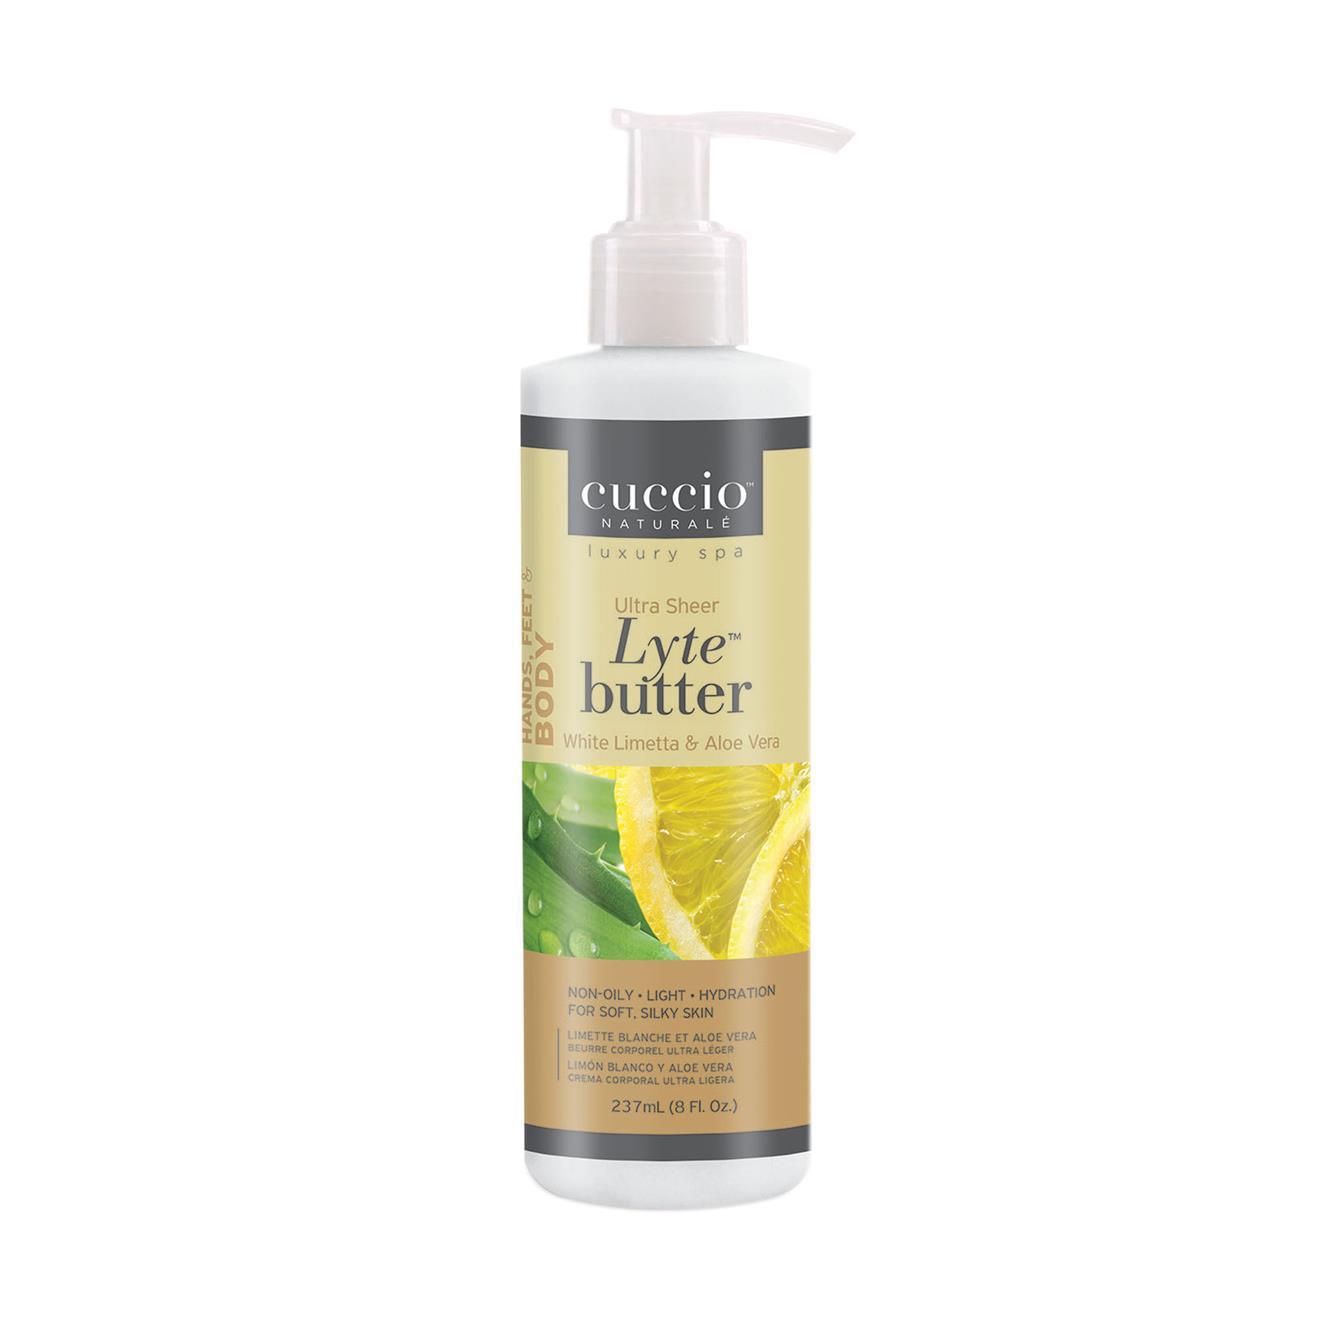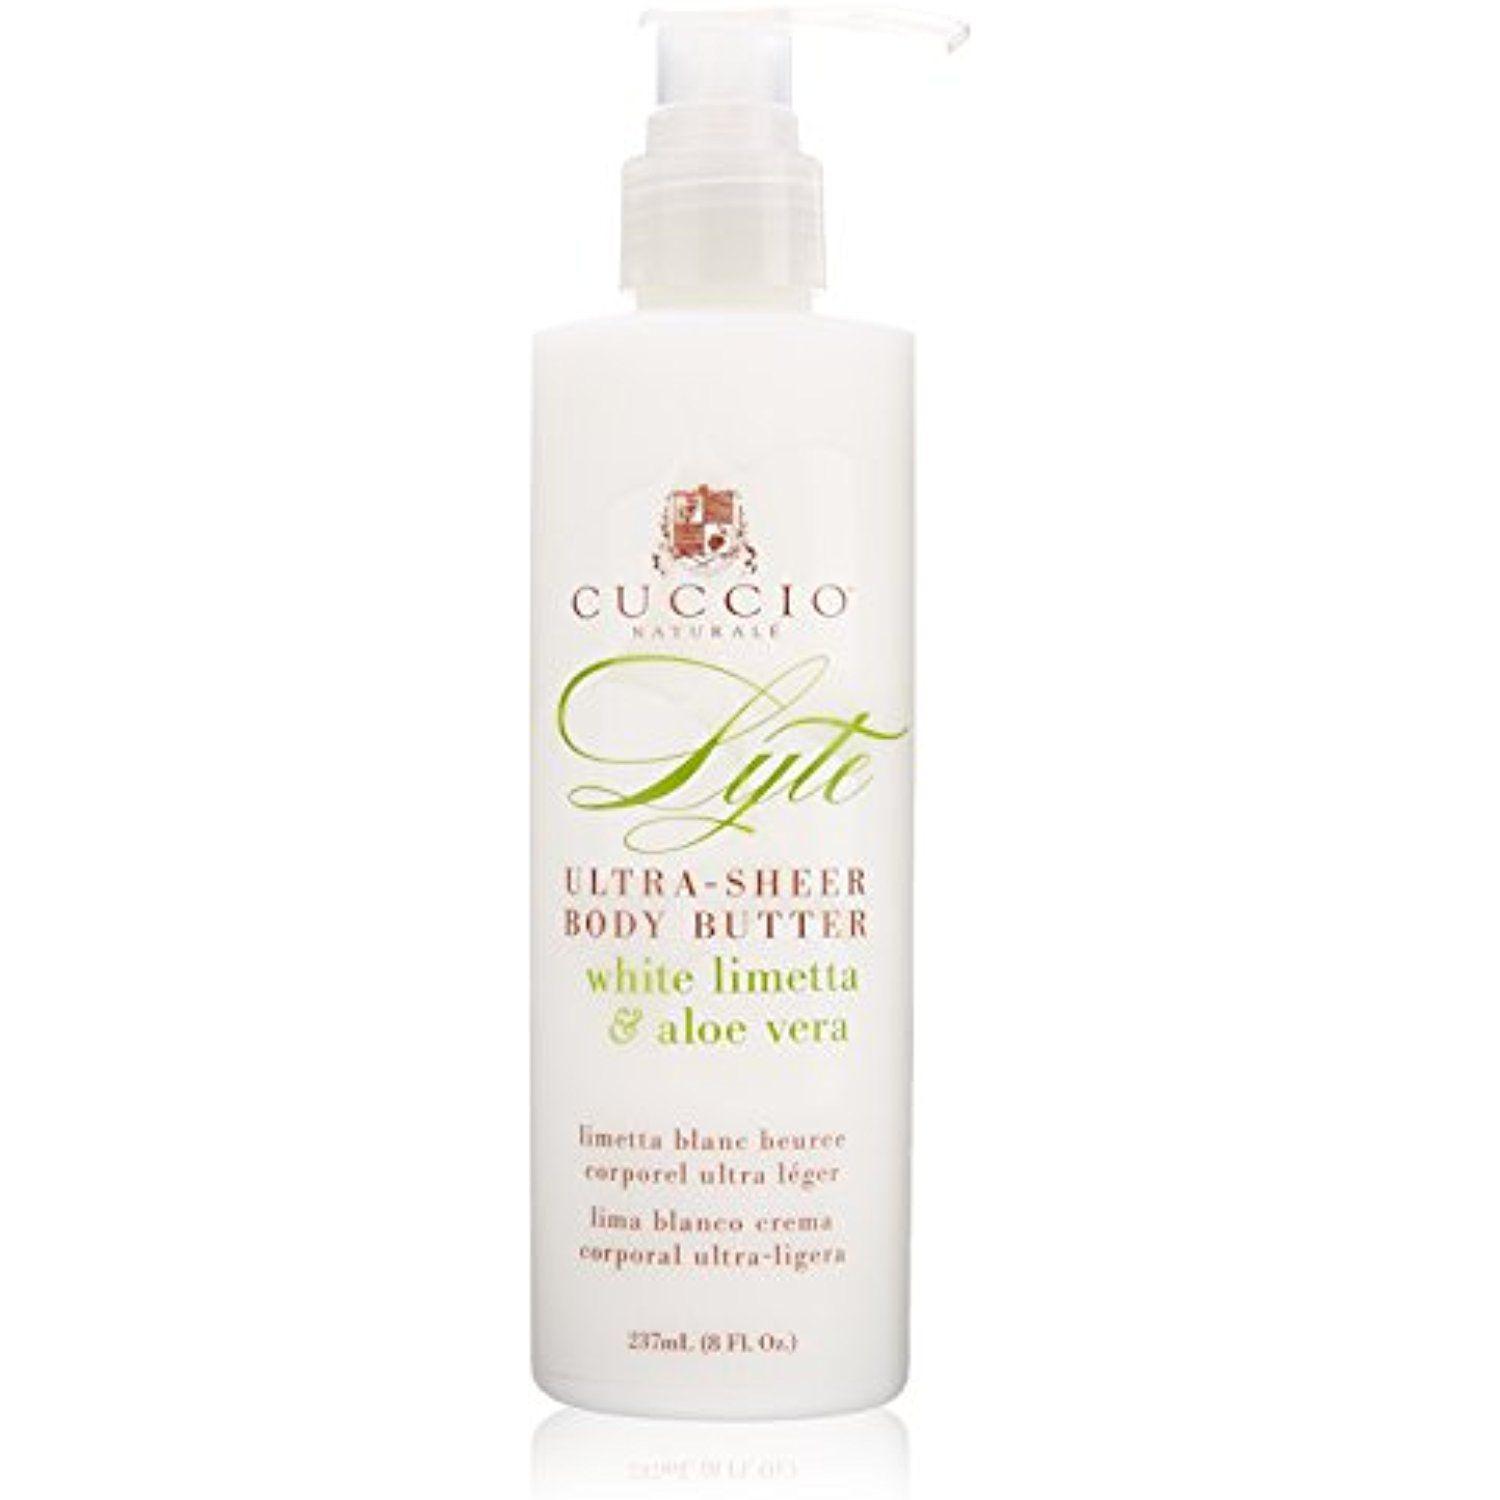The first image is the image on the left, the second image is the image on the right. For the images shown, is this caption "One bottle has yellow lemons on it." true? Answer yes or no. Yes. 